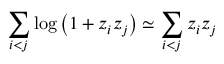<formula> <loc_0><loc_0><loc_500><loc_500>\sum _ { i < j } \log \left ( 1 + z _ { i } z _ { j } \right ) \simeq \sum _ { i < j } z _ { i } z _ { j }</formula> 